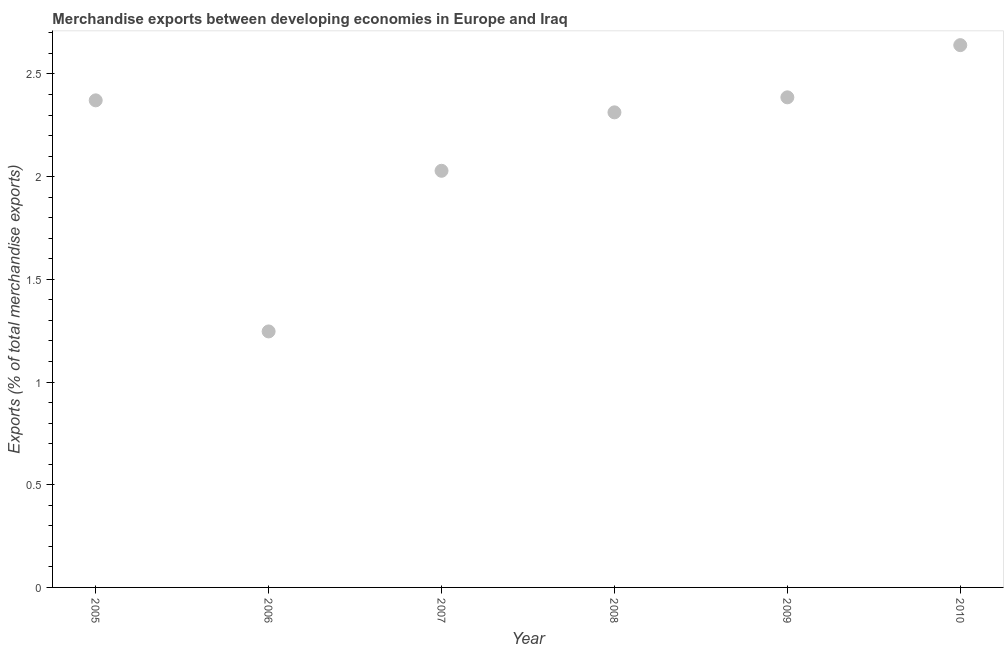What is the merchandise exports in 2005?
Your answer should be very brief. 2.37. Across all years, what is the maximum merchandise exports?
Your answer should be compact. 2.64. Across all years, what is the minimum merchandise exports?
Offer a terse response. 1.25. In which year was the merchandise exports minimum?
Provide a short and direct response. 2006. What is the sum of the merchandise exports?
Provide a short and direct response. 12.99. What is the difference between the merchandise exports in 2005 and 2008?
Your answer should be very brief. 0.06. What is the average merchandise exports per year?
Offer a terse response. 2.16. What is the median merchandise exports?
Your response must be concise. 2.34. Do a majority of the years between 2007 and 2006 (inclusive) have merchandise exports greater than 1.8 %?
Give a very brief answer. No. What is the ratio of the merchandise exports in 2006 to that in 2007?
Keep it short and to the point. 0.61. What is the difference between the highest and the second highest merchandise exports?
Give a very brief answer. 0.25. What is the difference between the highest and the lowest merchandise exports?
Ensure brevity in your answer.  1.39. In how many years, is the merchandise exports greater than the average merchandise exports taken over all years?
Offer a very short reply. 4. What is the difference between two consecutive major ticks on the Y-axis?
Keep it short and to the point. 0.5. Does the graph contain any zero values?
Offer a terse response. No. What is the title of the graph?
Provide a succinct answer. Merchandise exports between developing economies in Europe and Iraq. What is the label or title of the Y-axis?
Ensure brevity in your answer.  Exports (% of total merchandise exports). What is the Exports (% of total merchandise exports) in 2005?
Make the answer very short. 2.37. What is the Exports (% of total merchandise exports) in 2006?
Your response must be concise. 1.25. What is the Exports (% of total merchandise exports) in 2007?
Offer a very short reply. 2.03. What is the Exports (% of total merchandise exports) in 2008?
Keep it short and to the point. 2.31. What is the Exports (% of total merchandise exports) in 2009?
Offer a very short reply. 2.39. What is the Exports (% of total merchandise exports) in 2010?
Provide a short and direct response. 2.64. What is the difference between the Exports (% of total merchandise exports) in 2005 and 2006?
Offer a very short reply. 1.13. What is the difference between the Exports (% of total merchandise exports) in 2005 and 2007?
Your answer should be very brief. 0.34. What is the difference between the Exports (% of total merchandise exports) in 2005 and 2008?
Your response must be concise. 0.06. What is the difference between the Exports (% of total merchandise exports) in 2005 and 2009?
Ensure brevity in your answer.  -0.01. What is the difference between the Exports (% of total merchandise exports) in 2005 and 2010?
Give a very brief answer. -0.27. What is the difference between the Exports (% of total merchandise exports) in 2006 and 2007?
Provide a short and direct response. -0.78. What is the difference between the Exports (% of total merchandise exports) in 2006 and 2008?
Your answer should be compact. -1.07. What is the difference between the Exports (% of total merchandise exports) in 2006 and 2009?
Your answer should be compact. -1.14. What is the difference between the Exports (% of total merchandise exports) in 2006 and 2010?
Give a very brief answer. -1.39. What is the difference between the Exports (% of total merchandise exports) in 2007 and 2008?
Your answer should be compact. -0.28. What is the difference between the Exports (% of total merchandise exports) in 2007 and 2009?
Provide a succinct answer. -0.36. What is the difference between the Exports (% of total merchandise exports) in 2007 and 2010?
Offer a terse response. -0.61. What is the difference between the Exports (% of total merchandise exports) in 2008 and 2009?
Keep it short and to the point. -0.07. What is the difference between the Exports (% of total merchandise exports) in 2008 and 2010?
Keep it short and to the point. -0.33. What is the difference between the Exports (% of total merchandise exports) in 2009 and 2010?
Ensure brevity in your answer.  -0.25. What is the ratio of the Exports (% of total merchandise exports) in 2005 to that in 2006?
Ensure brevity in your answer.  1.9. What is the ratio of the Exports (% of total merchandise exports) in 2005 to that in 2007?
Keep it short and to the point. 1.17. What is the ratio of the Exports (% of total merchandise exports) in 2005 to that in 2009?
Provide a short and direct response. 0.99. What is the ratio of the Exports (% of total merchandise exports) in 2005 to that in 2010?
Your answer should be compact. 0.9. What is the ratio of the Exports (% of total merchandise exports) in 2006 to that in 2007?
Offer a very short reply. 0.61. What is the ratio of the Exports (% of total merchandise exports) in 2006 to that in 2008?
Make the answer very short. 0.54. What is the ratio of the Exports (% of total merchandise exports) in 2006 to that in 2009?
Give a very brief answer. 0.52. What is the ratio of the Exports (% of total merchandise exports) in 2006 to that in 2010?
Your answer should be compact. 0.47. What is the ratio of the Exports (% of total merchandise exports) in 2007 to that in 2008?
Provide a succinct answer. 0.88. What is the ratio of the Exports (% of total merchandise exports) in 2007 to that in 2010?
Keep it short and to the point. 0.77. What is the ratio of the Exports (% of total merchandise exports) in 2008 to that in 2009?
Your response must be concise. 0.97. What is the ratio of the Exports (% of total merchandise exports) in 2008 to that in 2010?
Your answer should be compact. 0.88. What is the ratio of the Exports (% of total merchandise exports) in 2009 to that in 2010?
Your answer should be very brief. 0.9. 